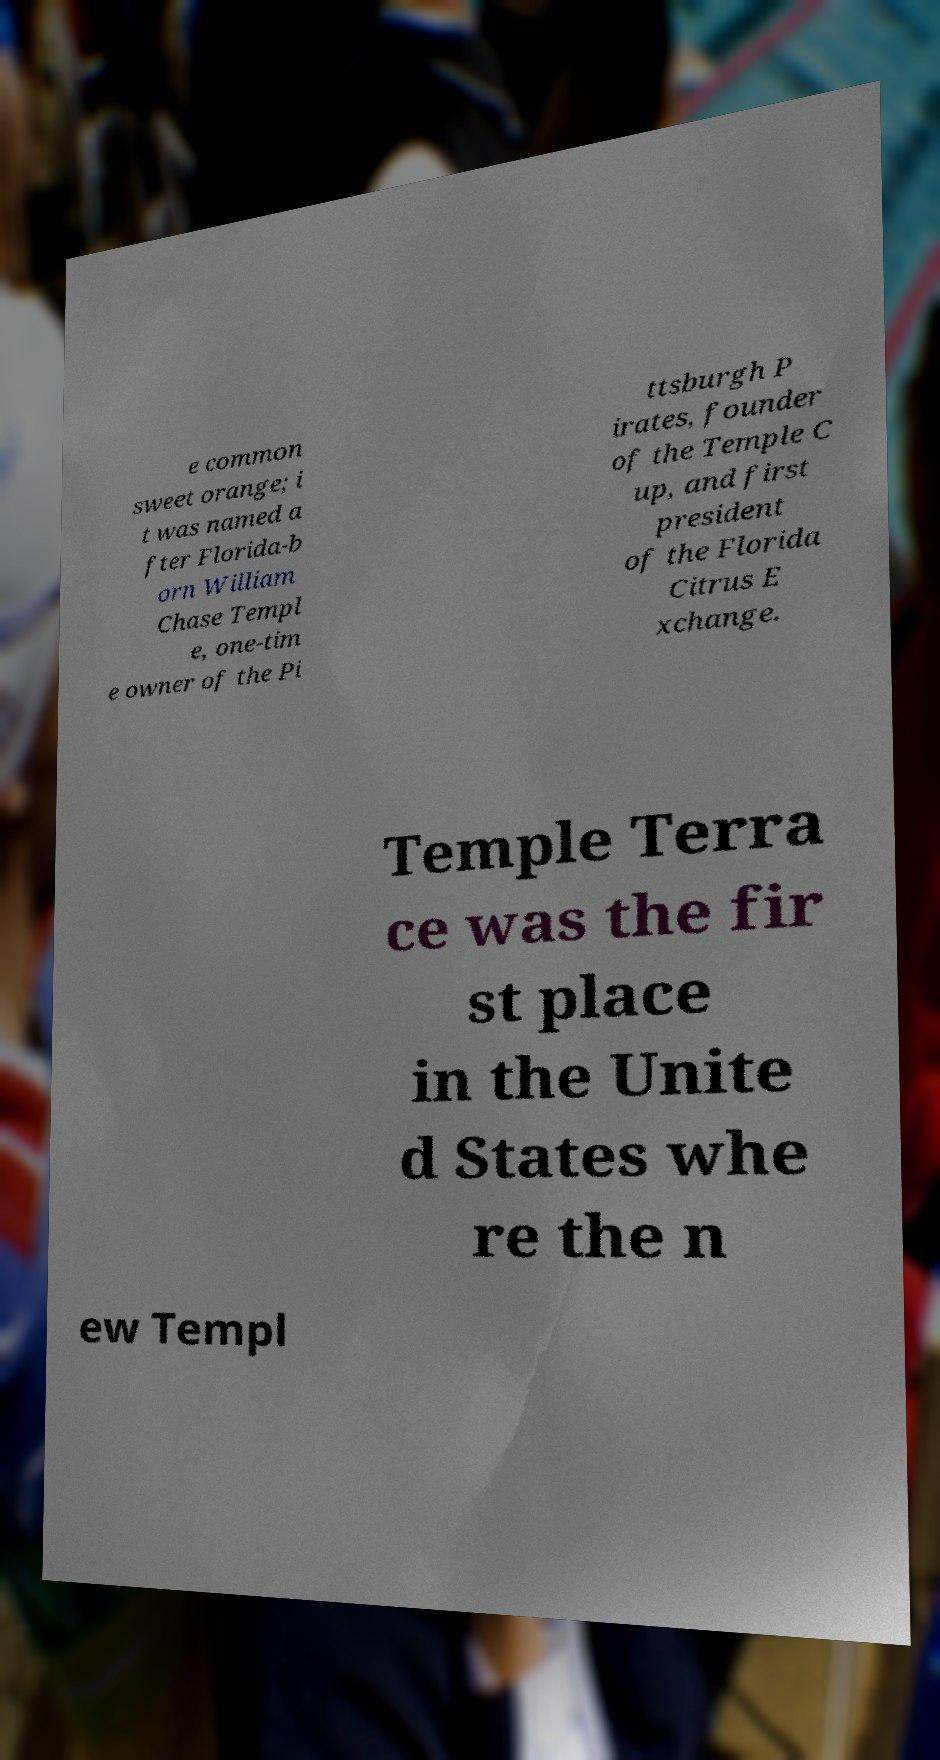Can you accurately transcribe the text from the provided image for me? e common sweet orange; i t was named a fter Florida-b orn William Chase Templ e, one-tim e owner of the Pi ttsburgh P irates, founder of the Temple C up, and first president of the Florida Citrus E xchange. Temple Terra ce was the fir st place in the Unite d States whe re the n ew Templ 